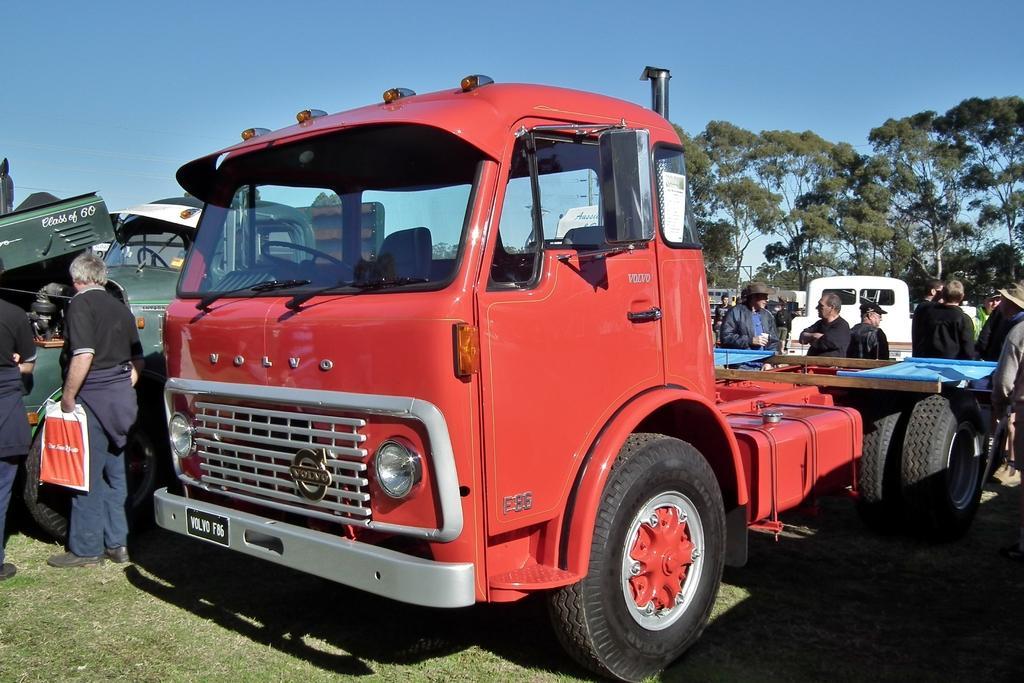Can you describe this image briefly? In this image there is the sky towards the top of the image, there are trees towards the right of the image, there are vehicles, there are a group of persons standing towards the right of the image, there are two men standing towards the left of the image, the man is holding an object, there is grass towards the bottom of the image. 